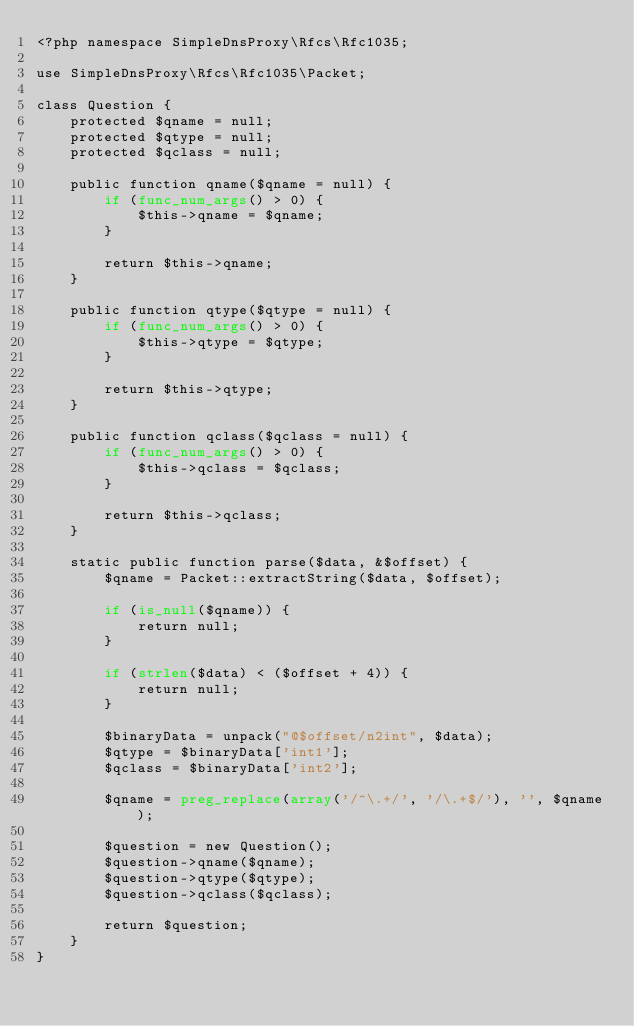Convert code to text. <code><loc_0><loc_0><loc_500><loc_500><_PHP_><?php namespace SimpleDnsProxy\Rfcs\Rfc1035;

use SimpleDnsProxy\Rfcs\Rfc1035\Packet;

class Question {
    protected $qname = null;
    protected $qtype = null;
    protected $qclass = null;

    public function qname($qname = null) {
        if (func_num_args() > 0) {
            $this->qname = $qname;
        }

        return $this->qname;
    }

    public function qtype($qtype = null) {
        if (func_num_args() > 0) {
            $this->qtype = $qtype;
        }

        return $this->qtype;
    }

    public function qclass($qclass = null) {
        if (func_num_args() > 0) {
            $this->qclass = $qclass;
        }

        return $this->qclass;
    }

    static public function parse($data, &$offset) {
        $qname = Packet::extractString($data, $offset);

        if (is_null($qname)) {
            return null;
        }

        if (strlen($data) < ($offset + 4)) {
            return null;
        }

        $binaryData = unpack("@$offset/n2int", $data);
        $qtype = $binaryData['int1'];
        $qclass = $binaryData['int2'];

        $qname = preg_replace(array('/^\.+/', '/\.+$/'), '', $qname);

        $question = new Question();
        $question->qname($qname);
        $question->qtype($qtype);
        $question->qclass($qclass);

        return $question;
    }
}</code> 